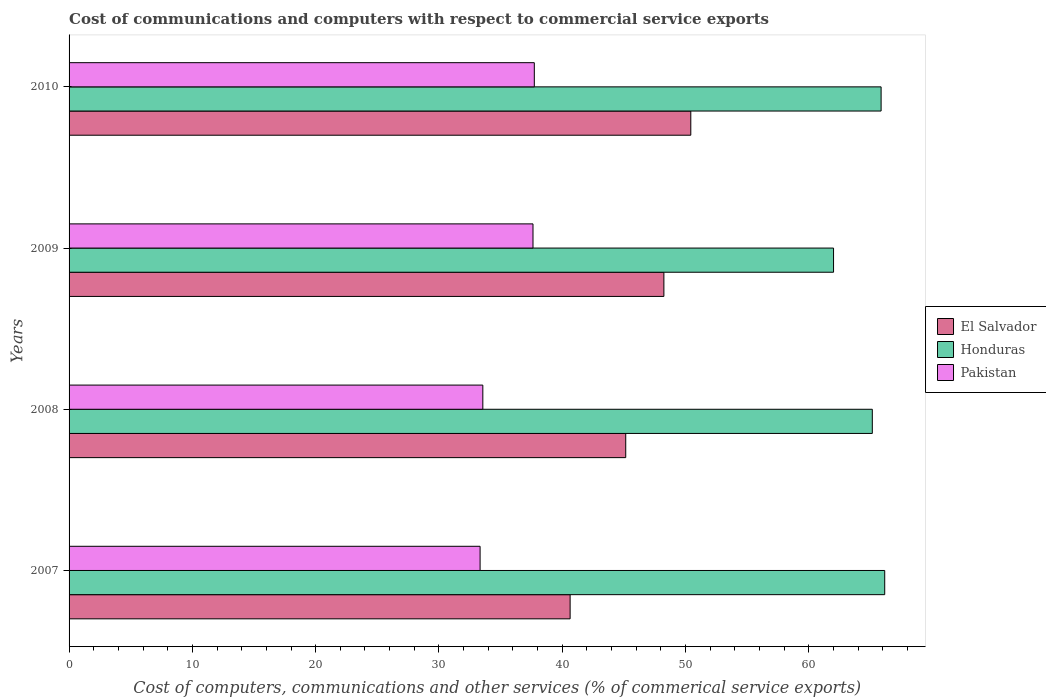How many groups of bars are there?
Your answer should be compact. 4. Are the number of bars on each tick of the Y-axis equal?
Provide a short and direct response. Yes. How many bars are there on the 1st tick from the bottom?
Provide a short and direct response. 3. In how many cases, is the number of bars for a given year not equal to the number of legend labels?
Ensure brevity in your answer.  0. What is the cost of communications and computers in Honduras in 2010?
Make the answer very short. 65.86. Across all years, what is the maximum cost of communications and computers in Pakistan?
Your answer should be compact. 37.73. Across all years, what is the minimum cost of communications and computers in Pakistan?
Ensure brevity in your answer.  33.34. In which year was the cost of communications and computers in Honduras maximum?
Make the answer very short. 2007. In which year was the cost of communications and computers in Honduras minimum?
Provide a short and direct response. 2009. What is the total cost of communications and computers in Pakistan in the graph?
Give a very brief answer. 142.26. What is the difference between the cost of communications and computers in Pakistan in 2007 and that in 2008?
Provide a short and direct response. -0.22. What is the difference between the cost of communications and computers in Honduras in 2010 and the cost of communications and computers in El Salvador in 2008?
Provide a succinct answer. 20.71. What is the average cost of communications and computers in Honduras per year?
Keep it short and to the point. 64.79. In the year 2007, what is the difference between the cost of communications and computers in Honduras and cost of communications and computers in Pakistan?
Keep it short and to the point. 32.82. What is the ratio of the cost of communications and computers in Pakistan in 2009 to that in 2010?
Your response must be concise. 1. What is the difference between the highest and the second highest cost of communications and computers in El Salvador?
Provide a short and direct response. 2.18. What is the difference between the highest and the lowest cost of communications and computers in Pakistan?
Make the answer very short. 4.4. In how many years, is the cost of communications and computers in Pakistan greater than the average cost of communications and computers in Pakistan taken over all years?
Offer a very short reply. 2. Is the sum of the cost of communications and computers in El Salvador in 2007 and 2010 greater than the maximum cost of communications and computers in Honduras across all years?
Provide a short and direct response. Yes. What does the 2nd bar from the top in 2010 represents?
Provide a short and direct response. Honduras. What does the 2nd bar from the bottom in 2007 represents?
Keep it short and to the point. Honduras. What is the difference between two consecutive major ticks on the X-axis?
Provide a short and direct response. 10. Does the graph contain any zero values?
Provide a succinct answer. No. Where does the legend appear in the graph?
Your answer should be compact. Center right. How are the legend labels stacked?
Give a very brief answer. Vertical. What is the title of the graph?
Your answer should be very brief. Cost of communications and computers with respect to commercial service exports. Does "Northern Mariana Islands" appear as one of the legend labels in the graph?
Your response must be concise. No. What is the label or title of the X-axis?
Keep it short and to the point. Cost of computers, communications and other services (% of commerical service exports). What is the Cost of computers, communications and other services (% of commerical service exports) of El Salvador in 2007?
Provide a short and direct response. 40.64. What is the Cost of computers, communications and other services (% of commerical service exports) in Honduras in 2007?
Ensure brevity in your answer.  66.16. What is the Cost of computers, communications and other services (% of commerical service exports) in Pakistan in 2007?
Your answer should be very brief. 33.34. What is the Cost of computers, communications and other services (% of commerical service exports) in El Salvador in 2008?
Offer a terse response. 45.15. What is the Cost of computers, communications and other services (% of commerical service exports) of Honduras in 2008?
Your answer should be very brief. 65.15. What is the Cost of computers, communications and other services (% of commerical service exports) of Pakistan in 2008?
Ensure brevity in your answer.  33.56. What is the Cost of computers, communications and other services (% of commerical service exports) in El Salvador in 2009?
Provide a short and direct response. 48.24. What is the Cost of computers, communications and other services (% of commerical service exports) in Honduras in 2009?
Keep it short and to the point. 62. What is the Cost of computers, communications and other services (% of commerical service exports) of Pakistan in 2009?
Give a very brief answer. 37.63. What is the Cost of computers, communications and other services (% of commerical service exports) of El Salvador in 2010?
Your response must be concise. 50.43. What is the Cost of computers, communications and other services (% of commerical service exports) of Honduras in 2010?
Keep it short and to the point. 65.86. What is the Cost of computers, communications and other services (% of commerical service exports) of Pakistan in 2010?
Offer a very short reply. 37.73. Across all years, what is the maximum Cost of computers, communications and other services (% of commerical service exports) in El Salvador?
Give a very brief answer. 50.43. Across all years, what is the maximum Cost of computers, communications and other services (% of commerical service exports) of Honduras?
Offer a very short reply. 66.16. Across all years, what is the maximum Cost of computers, communications and other services (% of commerical service exports) of Pakistan?
Offer a terse response. 37.73. Across all years, what is the minimum Cost of computers, communications and other services (% of commerical service exports) of El Salvador?
Make the answer very short. 40.64. Across all years, what is the minimum Cost of computers, communications and other services (% of commerical service exports) of Honduras?
Provide a short and direct response. 62. Across all years, what is the minimum Cost of computers, communications and other services (% of commerical service exports) in Pakistan?
Offer a terse response. 33.34. What is the total Cost of computers, communications and other services (% of commerical service exports) of El Salvador in the graph?
Your answer should be compact. 184.46. What is the total Cost of computers, communications and other services (% of commerical service exports) in Honduras in the graph?
Keep it short and to the point. 259.17. What is the total Cost of computers, communications and other services (% of commerical service exports) of Pakistan in the graph?
Your answer should be compact. 142.26. What is the difference between the Cost of computers, communications and other services (% of commerical service exports) in El Salvador in 2007 and that in 2008?
Ensure brevity in your answer.  -4.51. What is the difference between the Cost of computers, communications and other services (% of commerical service exports) in Honduras in 2007 and that in 2008?
Offer a very short reply. 1.01. What is the difference between the Cost of computers, communications and other services (% of commerical service exports) of Pakistan in 2007 and that in 2008?
Give a very brief answer. -0.22. What is the difference between the Cost of computers, communications and other services (% of commerical service exports) of El Salvador in 2007 and that in 2009?
Keep it short and to the point. -7.6. What is the difference between the Cost of computers, communications and other services (% of commerical service exports) in Honduras in 2007 and that in 2009?
Your response must be concise. 4.15. What is the difference between the Cost of computers, communications and other services (% of commerical service exports) in Pakistan in 2007 and that in 2009?
Your response must be concise. -4.29. What is the difference between the Cost of computers, communications and other services (% of commerical service exports) in El Salvador in 2007 and that in 2010?
Provide a short and direct response. -9.79. What is the difference between the Cost of computers, communications and other services (% of commerical service exports) in Honduras in 2007 and that in 2010?
Make the answer very short. 0.29. What is the difference between the Cost of computers, communications and other services (% of commerical service exports) of Pakistan in 2007 and that in 2010?
Your answer should be very brief. -4.4. What is the difference between the Cost of computers, communications and other services (% of commerical service exports) of El Salvador in 2008 and that in 2009?
Provide a succinct answer. -3.09. What is the difference between the Cost of computers, communications and other services (% of commerical service exports) in Honduras in 2008 and that in 2009?
Provide a succinct answer. 3.14. What is the difference between the Cost of computers, communications and other services (% of commerical service exports) in Pakistan in 2008 and that in 2009?
Provide a succinct answer. -4.07. What is the difference between the Cost of computers, communications and other services (% of commerical service exports) in El Salvador in 2008 and that in 2010?
Offer a terse response. -5.28. What is the difference between the Cost of computers, communications and other services (% of commerical service exports) in Honduras in 2008 and that in 2010?
Offer a terse response. -0.71. What is the difference between the Cost of computers, communications and other services (% of commerical service exports) in Pakistan in 2008 and that in 2010?
Your answer should be very brief. -4.18. What is the difference between the Cost of computers, communications and other services (% of commerical service exports) of El Salvador in 2009 and that in 2010?
Offer a very short reply. -2.18. What is the difference between the Cost of computers, communications and other services (% of commerical service exports) in Honduras in 2009 and that in 2010?
Make the answer very short. -3.86. What is the difference between the Cost of computers, communications and other services (% of commerical service exports) of Pakistan in 2009 and that in 2010?
Offer a very short reply. -0.11. What is the difference between the Cost of computers, communications and other services (% of commerical service exports) of El Salvador in 2007 and the Cost of computers, communications and other services (% of commerical service exports) of Honduras in 2008?
Keep it short and to the point. -24.51. What is the difference between the Cost of computers, communications and other services (% of commerical service exports) of El Salvador in 2007 and the Cost of computers, communications and other services (% of commerical service exports) of Pakistan in 2008?
Provide a succinct answer. 7.08. What is the difference between the Cost of computers, communications and other services (% of commerical service exports) of Honduras in 2007 and the Cost of computers, communications and other services (% of commerical service exports) of Pakistan in 2008?
Your answer should be compact. 32.6. What is the difference between the Cost of computers, communications and other services (% of commerical service exports) of El Salvador in 2007 and the Cost of computers, communications and other services (% of commerical service exports) of Honduras in 2009?
Keep it short and to the point. -21.36. What is the difference between the Cost of computers, communications and other services (% of commerical service exports) in El Salvador in 2007 and the Cost of computers, communications and other services (% of commerical service exports) in Pakistan in 2009?
Your answer should be very brief. 3.01. What is the difference between the Cost of computers, communications and other services (% of commerical service exports) in Honduras in 2007 and the Cost of computers, communications and other services (% of commerical service exports) in Pakistan in 2009?
Provide a short and direct response. 28.53. What is the difference between the Cost of computers, communications and other services (% of commerical service exports) of El Salvador in 2007 and the Cost of computers, communications and other services (% of commerical service exports) of Honduras in 2010?
Offer a terse response. -25.22. What is the difference between the Cost of computers, communications and other services (% of commerical service exports) in El Salvador in 2007 and the Cost of computers, communications and other services (% of commerical service exports) in Pakistan in 2010?
Offer a very short reply. 2.91. What is the difference between the Cost of computers, communications and other services (% of commerical service exports) in Honduras in 2007 and the Cost of computers, communications and other services (% of commerical service exports) in Pakistan in 2010?
Your response must be concise. 28.42. What is the difference between the Cost of computers, communications and other services (% of commerical service exports) of El Salvador in 2008 and the Cost of computers, communications and other services (% of commerical service exports) of Honduras in 2009?
Offer a terse response. -16.85. What is the difference between the Cost of computers, communications and other services (% of commerical service exports) in El Salvador in 2008 and the Cost of computers, communications and other services (% of commerical service exports) in Pakistan in 2009?
Ensure brevity in your answer.  7.52. What is the difference between the Cost of computers, communications and other services (% of commerical service exports) of Honduras in 2008 and the Cost of computers, communications and other services (% of commerical service exports) of Pakistan in 2009?
Make the answer very short. 27.52. What is the difference between the Cost of computers, communications and other services (% of commerical service exports) of El Salvador in 2008 and the Cost of computers, communications and other services (% of commerical service exports) of Honduras in 2010?
Provide a short and direct response. -20.71. What is the difference between the Cost of computers, communications and other services (% of commerical service exports) in El Salvador in 2008 and the Cost of computers, communications and other services (% of commerical service exports) in Pakistan in 2010?
Offer a very short reply. 7.42. What is the difference between the Cost of computers, communications and other services (% of commerical service exports) of Honduras in 2008 and the Cost of computers, communications and other services (% of commerical service exports) of Pakistan in 2010?
Give a very brief answer. 27.41. What is the difference between the Cost of computers, communications and other services (% of commerical service exports) of El Salvador in 2009 and the Cost of computers, communications and other services (% of commerical service exports) of Honduras in 2010?
Make the answer very short. -17.62. What is the difference between the Cost of computers, communications and other services (% of commerical service exports) of El Salvador in 2009 and the Cost of computers, communications and other services (% of commerical service exports) of Pakistan in 2010?
Your answer should be very brief. 10.51. What is the difference between the Cost of computers, communications and other services (% of commerical service exports) in Honduras in 2009 and the Cost of computers, communications and other services (% of commerical service exports) in Pakistan in 2010?
Keep it short and to the point. 24.27. What is the average Cost of computers, communications and other services (% of commerical service exports) of El Salvador per year?
Offer a terse response. 46.12. What is the average Cost of computers, communications and other services (% of commerical service exports) of Honduras per year?
Provide a short and direct response. 64.79. What is the average Cost of computers, communications and other services (% of commerical service exports) in Pakistan per year?
Your answer should be compact. 35.56. In the year 2007, what is the difference between the Cost of computers, communications and other services (% of commerical service exports) in El Salvador and Cost of computers, communications and other services (% of commerical service exports) in Honduras?
Your answer should be compact. -25.52. In the year 2007, what is the difference between the Cost of computers, communications and other services (% of commerical service exports) in El Salvador and Cost of computers, communications and other services (% of commerical service exports) in Pakistan?
Offer a very short reply. 7.3. In the year 2007, what is the difference between the Cost of computers, communications and other services (% of commerical service exports) in Honduras and Cost of computers, communications and other services (% of commerical service exports) in Pakistan?
Provide a succinct answer. 32.82. In the year 2008, what is the difference between the Cost of computers, communications and other services (% of commerical service exports) in El Salvador and Cost of computers, communications and other services (% of commerical service exports) in Honduras?
Ensure brevity in your answer.  -20. In the year 2008, what is the difference between the Cost of computers, communications and other services (% of commerical service exports) in El Salvador and Cost of computers, communications and other services (% of commerical service exports) in Pakistan?
Give a very brief answer. 11.59. In the year 2008, what is the difference between the Cost of computers, communications and other services (% of commerical service exports) of Honduras and Cost of computers, communications and other services (% of commerical service exports) of Pakistan?
Give a very brief answer. 31.59. In the year 2009, what is the difference between the Cost of computers, communications and other services (% of commerical service exports) of El Salvador and Cost of computers, communications and other services (% of commerical service exports) of Honduras?
Your answer should be very brief. -13.76. In the year 2009, what is the difference between the Cost of computers, communications and other services (% of commerical service exports) of El Salvador and Cost of computers, communications and other services (% of commerical service exports) of Pakistan?
Give a very brief answer. 10.62. In the year 2009, what is the difference between the Cost of computers, communications and other services (% of commerical service exports) of Honduras and Cost of computers, communications and other services (% of commerical service exports) of Pakistan?
Ensure brevity in your answer.  24.38. In the year 2010, what is the difference between the Cost of computers, communications and other services (% of commerical service exports) in El Salvador and Cost of computers, communications and other services (% of commerical service exports) in Honduras?
Make the answer very short. -15.43. In the year 2010, what is the difference between the Cost of computers, communications and other services (% of commerical service exports) in El Salvador and Cost of computers, communications and other services (% of commerical service exports) in Pakistan?
Keep it short and to the point. 12.69. In the year 2010, what is the difference between the Cost of computers, communications and other services (% of commerical service exports) of Honduras and Cost of computers, communications and other services (% of commerical service exports) of Pakistan?
Offer a very short reply. 28.13. What is the ratio of the Cost of computers, communications and other services (% of commerical service exports) of El Salvador in 2007 to that in 2008?
Keep it short and to the point. 0.9. What is the ratio of the Cost of computers, communications and other services (% of commerical service exports) in Honduras in 2007 to that in 2008?
Your response must be concise. 1.02. What is the ratio of the Cost of computers, communications and other services (% of commerical service exports) in El Salvador in 2007 to that in 2009?
Offer a terse response. 0.84. What is the ratio of the Cost of computers, communications and other services (% of commerical service exports) in Honduras in 2007 to that in 2009?
Provide a short and direct response. 1.07. What is the ratio of the Cost of computers, communications and other services (% of commerical service exports) of Pakistan in 2007 to that in 2009?
Provide a succinct answer. 0.89. What is the ratio of the Cost of computers, communications and other services (% of commerical service exports) in El Salvador in 2007 to that in 2010?
Keep it short and to the point. 0.81. What is the ratio of the Cost of computers, communications and other services (% of commerical service exports) in Honduras in 2007 to that in 2010?
Give a very brief answer. 1. What is the ratio of the Cost of computers, communications and other services (% of commerical service exports) in Pakistan in 2007 to that in 2010?
Provide a succinct answer. 0.88. What is the ratio of the Cost of computers, communications and other services (% of commerical service exports) of El Salvador in 2008 to that in 2009?
Provide a short and direct response. 0.94. What is the ratio of the Cost of computers, communications and other services (% of commerical service exports) of Honduras in 2008 to that in 2009?
Offer a terse response. 1.05. What is the ratio of the Cost of computers, communications and other services (% of commerical service exports) of Pakistan in 2008 to that in 2009?
Make the answer very short. 0.89. What is the ratio of the Cost of computers, communications and other services (% of commerical service exports) of El Salvador in 2008 to that in 2010?
Keep it short and to the point. 0.9. What is the ratio of the Cost of computers, communications and other services (% of commerical service exports) of Honduras in 2008 to that in 2010?
Your answer should be very brief. 0.99. What is the ratio of the Cost of computers, communications and other services (% of commerical service exports) of Pakistan in 2008 to that in 2010?
Keep it short and to the point. 0.89. What is the ratio of the Cost of computers, communications and other services (% of commerical service exports) in El Salvador in 2009 to that in 2010?
Offer a very short reply. 0.96. What is the ratio of the Cost of computers, communications and other services (% of commerical service exports) of Honduras in 2009 to that in 2010?
Offer a terse response. 0.94. What is the difference between the highest and the second highest Cost of computers, communications and other services (% of commerical service exports) of El Salvador?
Provide a succinct answer. 2.18. What is the difference between the highest and the second highest Cost of computers, communications and other services (% of commerical service exports) in Honduras?
Ensure brevity in your answer.  0.29. What is the difference between the highest and the second highest Cost of computers, communications and other services (% of commerical service exports) of Pakistan?
Your response must be concise. 0.11. What is the difference between the highest and the lowest Cost of computers, communications and other services (% of commerical service exports) in El Salvador?
Your answer should be very brief. 9.79. What is the difference between the highest and the lowest Cost of computers, communications and other services (% of commerical service exports) of Honduras?
Make the answer very short. 4.15. What is the difference between the highest and the lowest Cost of computers, communications and other services (% of commerical service exports) in Pakistan?
Make the answer very short. 4.4. 